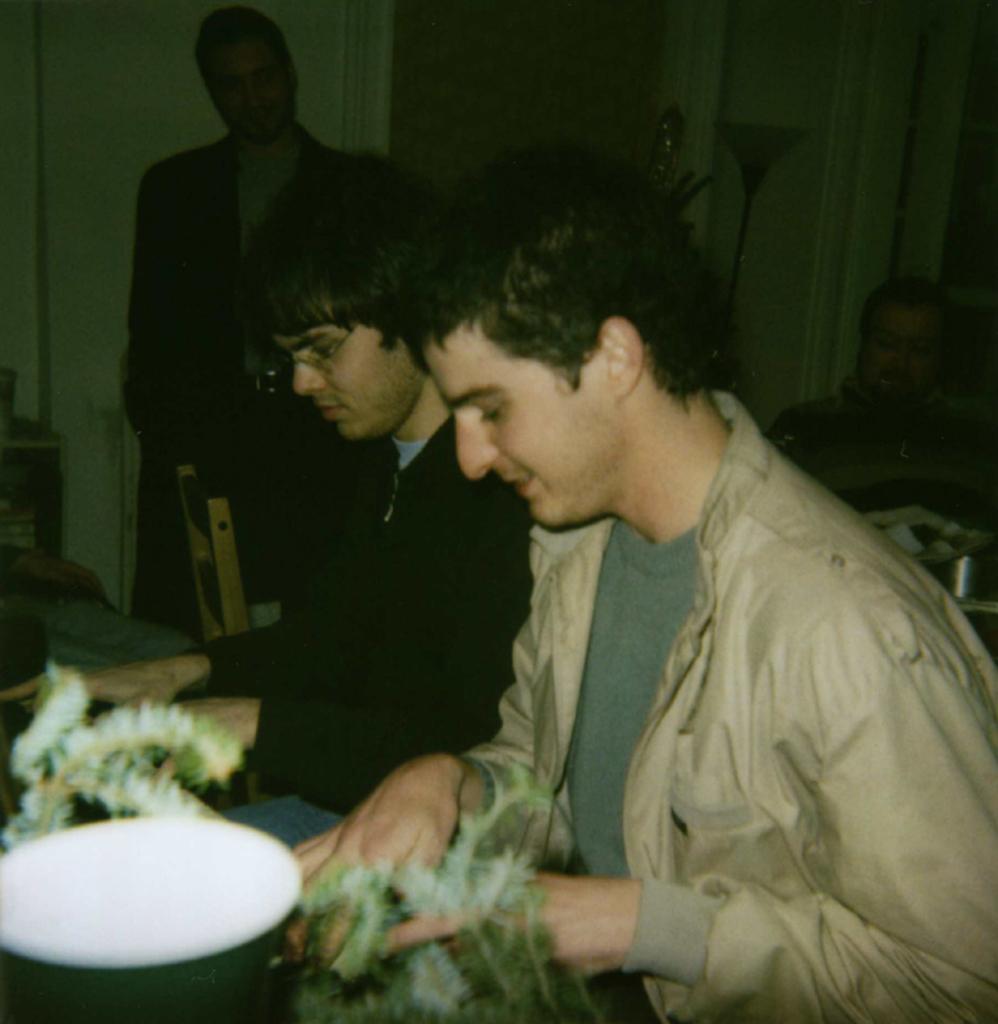Describe this image in one or two sentences. In this picture we can see two men sitting on the chair. There is a bowl and other objects on the table. We can see two people at the back. There are a few objects visible in the background. We can see a dark background. 